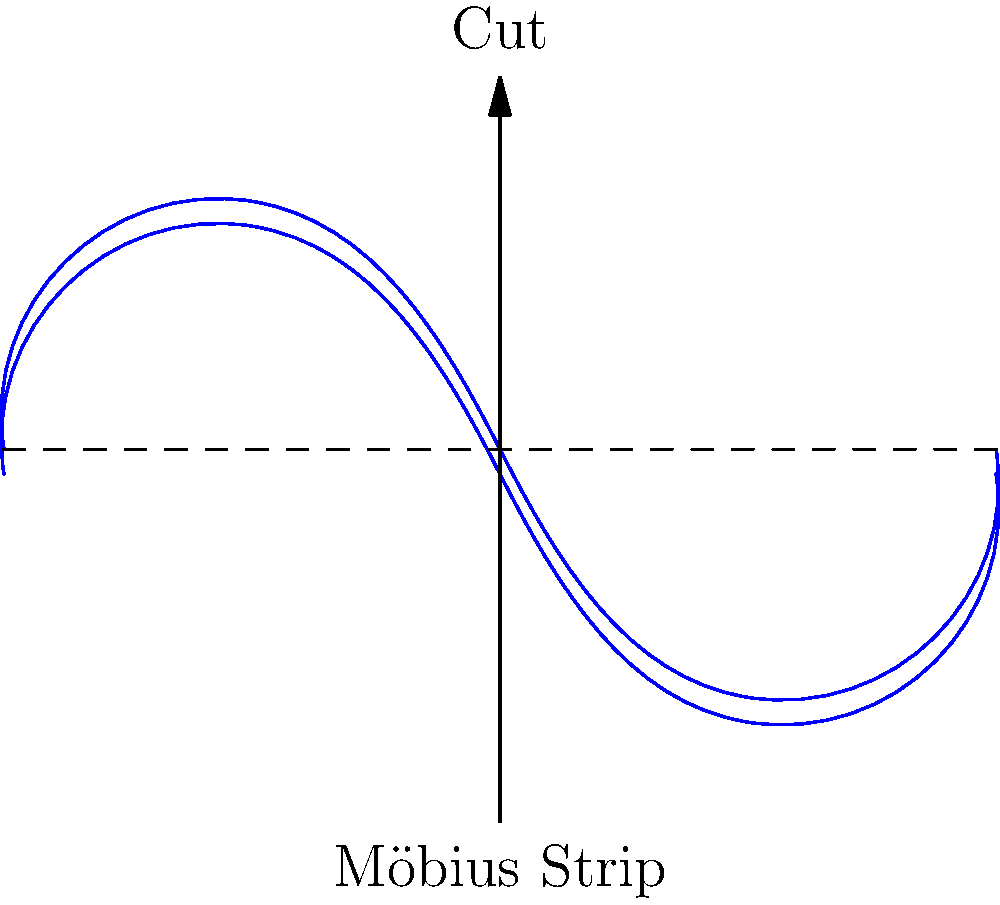As a storyteller with a unique style, imagine incorporating the Möbius strip into your narrative. If a character were to cut this one-sided surface lengthwise, what surprising outcome would they encounter, and how might this reflect the non-linear nature of your storytelling? To understand the outcome of cutting a Möbius strip lengthwise, let's break it down step-by-step:

1. A Möbius strip is a surface with only one side and one edge, created by taking a strip of paper, giving it a half-twist, and joining the ends.

2. When cut lengthwise down the center:
   a. The cut doesn't separate the strip into two pieces.
   b. Instead, it creates one longer strip with two full twists.

3. This happens because:
   - As you cut, you're simultaneously cutting both "sides" of the original strip.
   - The half-twist causes the cut to meet back at the starting point after traversing the entire length twice.

4. The resulting strip is twice as long as the original and has two full twists.

5. Interestingly, this new strip is no longer a Möbius strip, as it now has two sides and two edges.

6. If this longer strip were cut lengthwise again, it would separate into two interlocked rings, each with two full twists.

This paradoxical behavior mirrors non-linear storytelling techniques:
- Just as the cut reveals hidden complexity in the Möbius strip, non-linear narratives can unveil layers of depth in a story.
- The transformation of the strip reflects how a seemingly simple narrative can unfold into a more complex structure.
- The interconnectedness of the resulting longer strip parallels how different story elements can be intricately linked in unexpected ways.
Answer: One longer strip with two full twists 